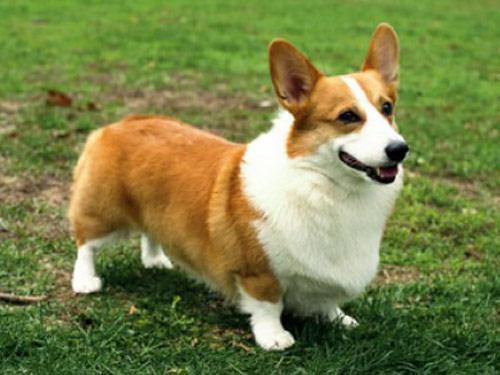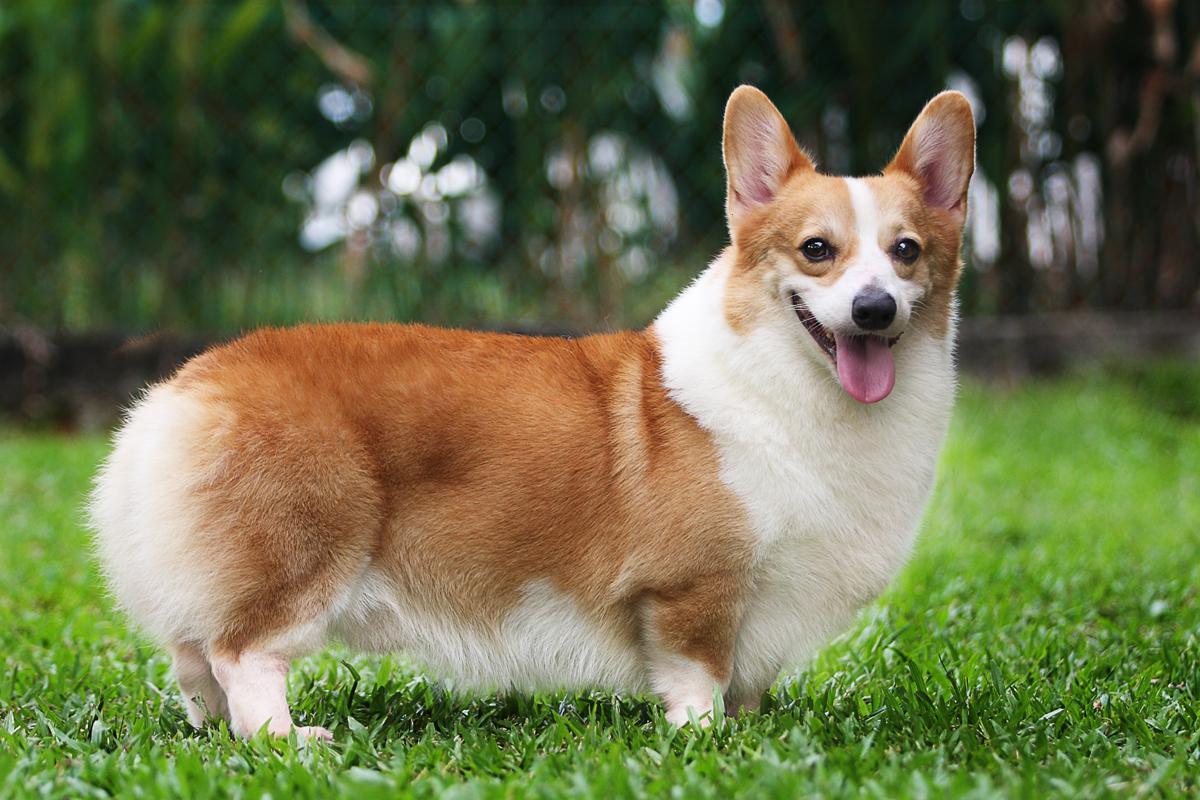The first image is the image on the left, the second image is the image on the right. Analyze the images presented: Is the assertion "Both images show short-legged dogs standing on grass." valid? Answer yes or no. Yes. The first image is the image on the left, the second image is the image on the right. Considering the images on both sides, is "The bodies of the dogs in the two images turn toward each other." valid? Answer yes or no. No. The first image is the image on the left, the second image is the image on the right. For the images displayed, is the sentence "There are two dogs facing each other." factually correct? Answer yes or no. No. 